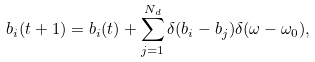<formula> <loc_0><loc_0><loc_500><loc_500>b _ { i } ( t + 1 ) = b _ { i } ( t ) + \sum _ { j = 1 } ^ { N _ { d } } \delta ( b _ { i } - b _ { j } ) \delta ( \omega - \omega _ { 0 } ) ,</formula> 